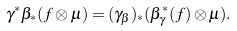<formula> <loc_0><loc_0><loc_500><loc_500>\gamma ^ { * } \beta _ { * } ( f \otimes \mu ) = ( \gamma _ { \beta } ) _ { * } ( \beta _ { \gamma } ^ { * } ( f ) \otimes \mu ) .</formula> 